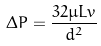Convert formula to latex. <formula><loc_0><loc_0><loc_500><loc_500>\Delta P = \frac { 3 2 \mu L v } { d ^ { 2 } }</formula> 